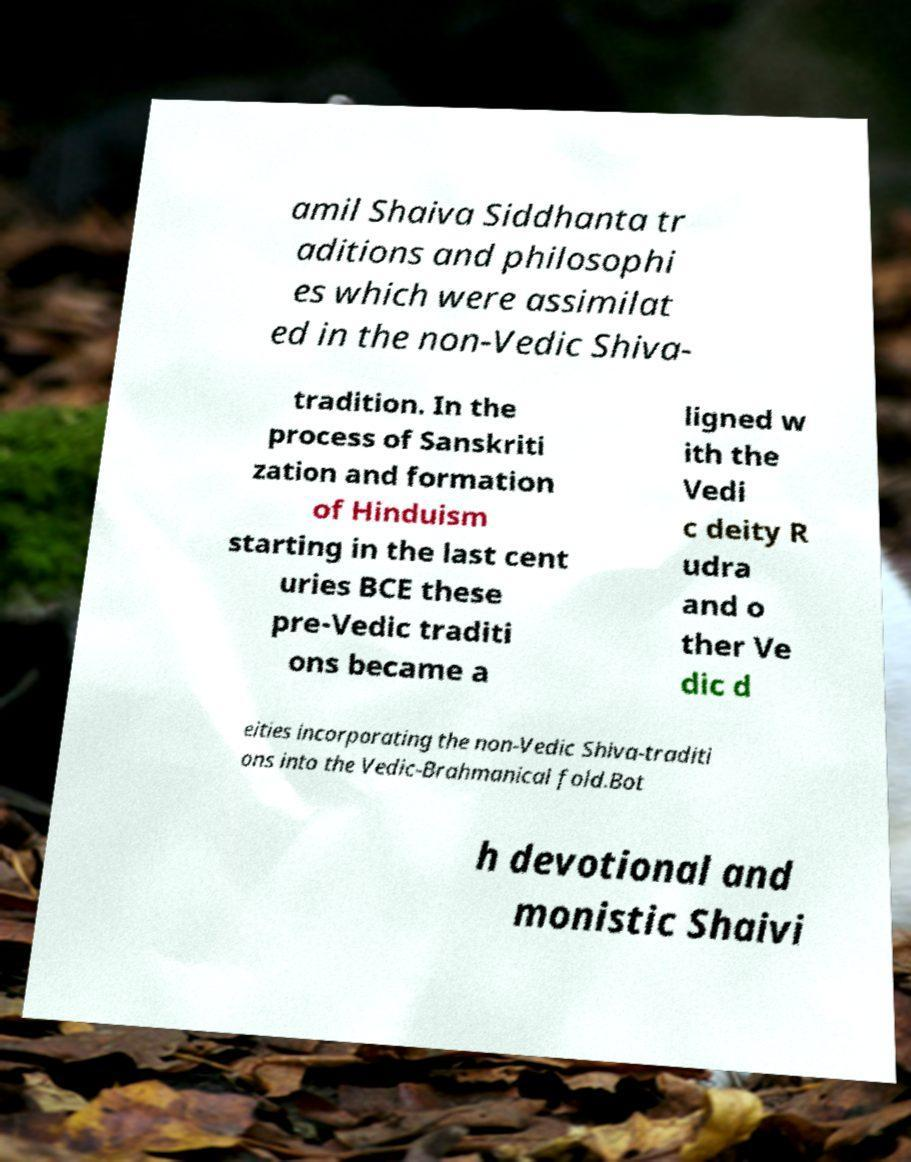Can you read and provide the text displayed in the image?This photo seems to have some interesting text. Can you extract and type it out for me? amil Shaiva Siddhanta tr aditions and philosophi es which were assimilat ed in the non-Vedic Shiva- tradition. In the process of Sanskriti zation and formation of Hinduism starting in the last cent uries BCE these pre-Vedic traditi ons became a ligned w ith the Vedi c deity R udra and o ther Ve dic d eities incorporating the non-Vedic Shiva-traditi ons into the Vedic-Brahmanical fold.Bot h devotional and monistic Shaivi 